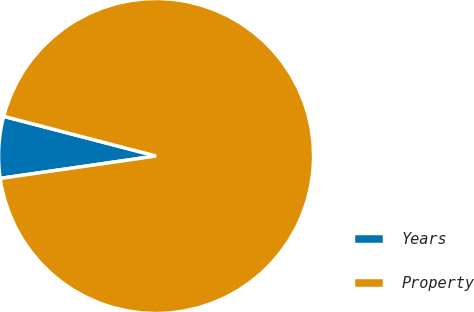<chart> <loc_0><loc_0><loc_500><loc_500><pie_chart><fcel>Years<fcel>Property<nl><fcel>6.33%<fcel>93.67%<nl></chart> 